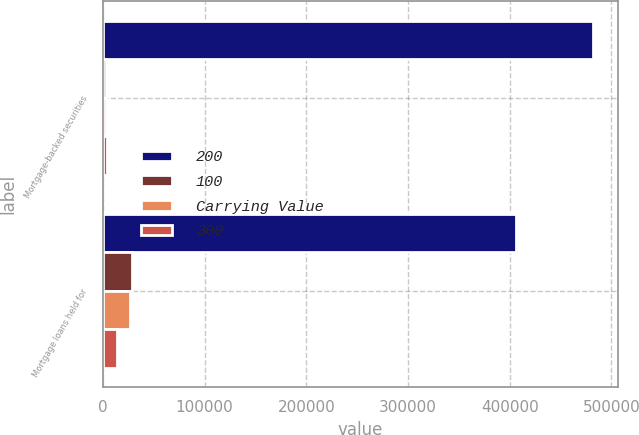<chart> <loc_0><loc_0><loc_500><loc_500><stacked_bar_chart><ecel><fcel>Mortgage-backed securities<fcel>Mortgage loans held for<nl><fcel>200<fcel>482378<fcel>406201<nl><fcel>100<fcel>3450<fcel>28689<nl><fcel>Carrying Value<fcel>3472<fcel>26403<nl><fcel>300<fcel>4067<fcel>13610<nl></chart> 